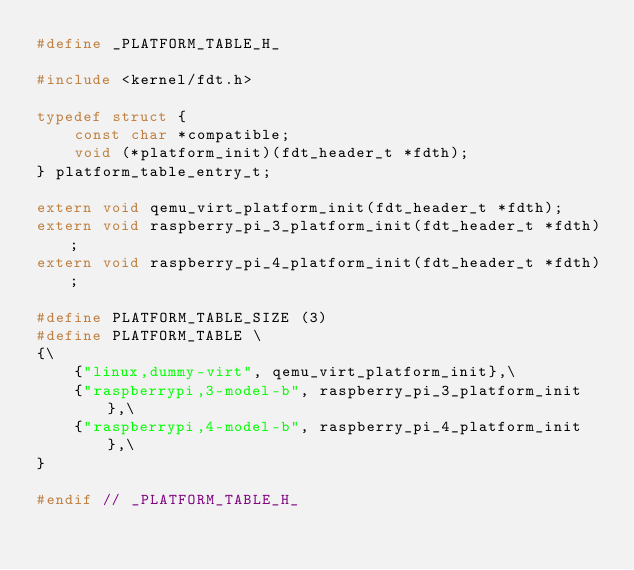<code> <loc_0><loc_0><loc_500><loc_500><_C_>#define _PLATFORM_TABLE_H_

#include <kernel/fdt.h>

typedef struct {
    const char *compatible;
    void (*platform_init)(fdt_header_t *fdth);
} platform_table_entry_t;

extern void qemu_virt_platform_init(fdt_header_t *fdth);
extern void raspberry_pi_3_platform_init(fdt_header_t *fdth);
extern void raspberry_pi_4_platform_init(fdt_header_t *fdth);

#define PLATFORM_TABLE_SIZE (3)
#define PLATFORM_TABLE \
{\
    {"linux,dummy-virt", qemu_virt_platform_init},\
    {"raspberrypi,3-model-b", raspberry_pi_3_platform_init},\
    {"raspberrypi,4-model-b", raspberry_pi_4_platform_init},\
}

#endif // _PLATFORM_TABLE_H_
</code> 